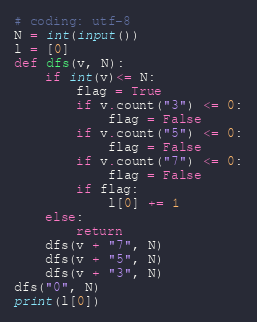<code> <loc_0><loc_0><loc_500><loc_500><_Python_># coding: utf-8
N = int(input())
l = [0]
def dfs(v, N):
    if int(v)<= N:
        flag = True
        if v.count("3") <= 0:
            flag = False
        if v.count("5") <= 0:
            flag = False
        if v.count("7") <= 0:
            flag = False
        if flag:
            l[0] += 1
    else:
        return
    dfs(v + "7", N)
    dfs(v + "5", N)
    dfs(v + "3", N)
dfs("0", N)
print(l[0])

</code> 